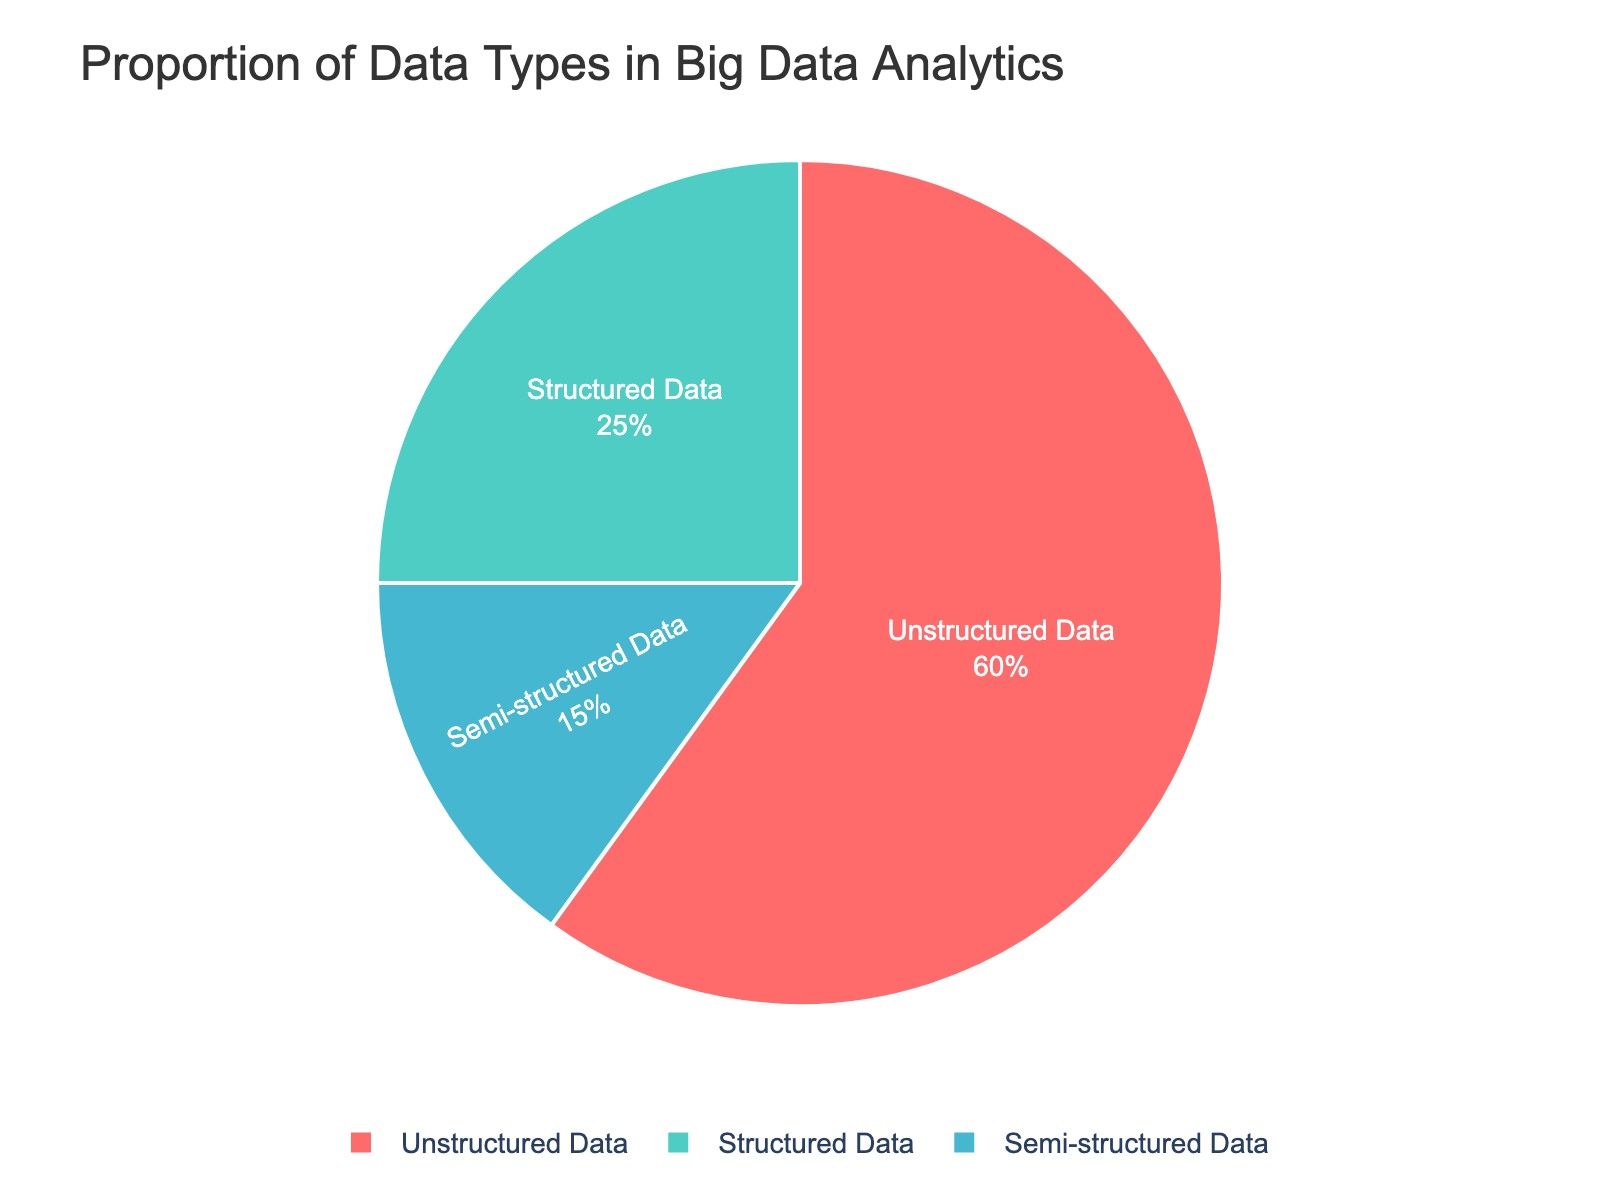What proportion of the data types is unstructured? The pie chart shows the percentage of unstructured data is 60%.
Answer: 60% Which data type has the smallest proportion in the dataset? From the pie chart, semi-structured data has the smallest slice, indicating the smallest proportion at 15%.
Answer: Semi-structured data What is the difference in proportion between structured and unstructured data? The pie chart indicates unstructured data is 60% and structured data is 25%, so the difference is 60% - 25% = 35%.
Answer: 35% What is the combined proportion of structured and semi-structured data? The percentages for structured and semi-structured data are 25% and 15%, respectively. Adding them together: 25% + 15% = 40%.
Answer: 40% What color represents unstructured data in the pie chart? The pie chart uses a custom color palette where unstructured data is shown in a turquoise green slice, which corresponds to 60% of the chart.
Answer: Turquoise green Which data type is shown in red, and what is its proportion? The red section of the pie chart represents structured data, which makes up 25% of the dataset.
Answer: Structured data, 25% How much larger is the proportion of unstructured data compared to semi-structured data? Unstructured data is 60% and semi-structured data is 15%. The absolute difference is 60% - 15% = 45%.
Answer: 45% In terms of proportion, is structured data closer to semi-structured data or unstructured data? Structured data is 25%, and the proportion of semi-structured data is 15%, while unstructured data is 60%. The difference between structured and semi-structured data is 25% - 15% = 10%, and the difference between structured and unstructured data is 60% - 25% = 35%. Since 10% < 35%, structured data is closer to semi-structured data.
Answer: Semi-structured data What two data types together make up more than half of the total proportion? Combining the proportions of unstructured data (60%) and any other would exceed 50%. Specifically, unstructured data (60%) and either structured data (25%) or semi-structured data (15%) will yield more than 50%.
Answer: Unstructured data and either other type 